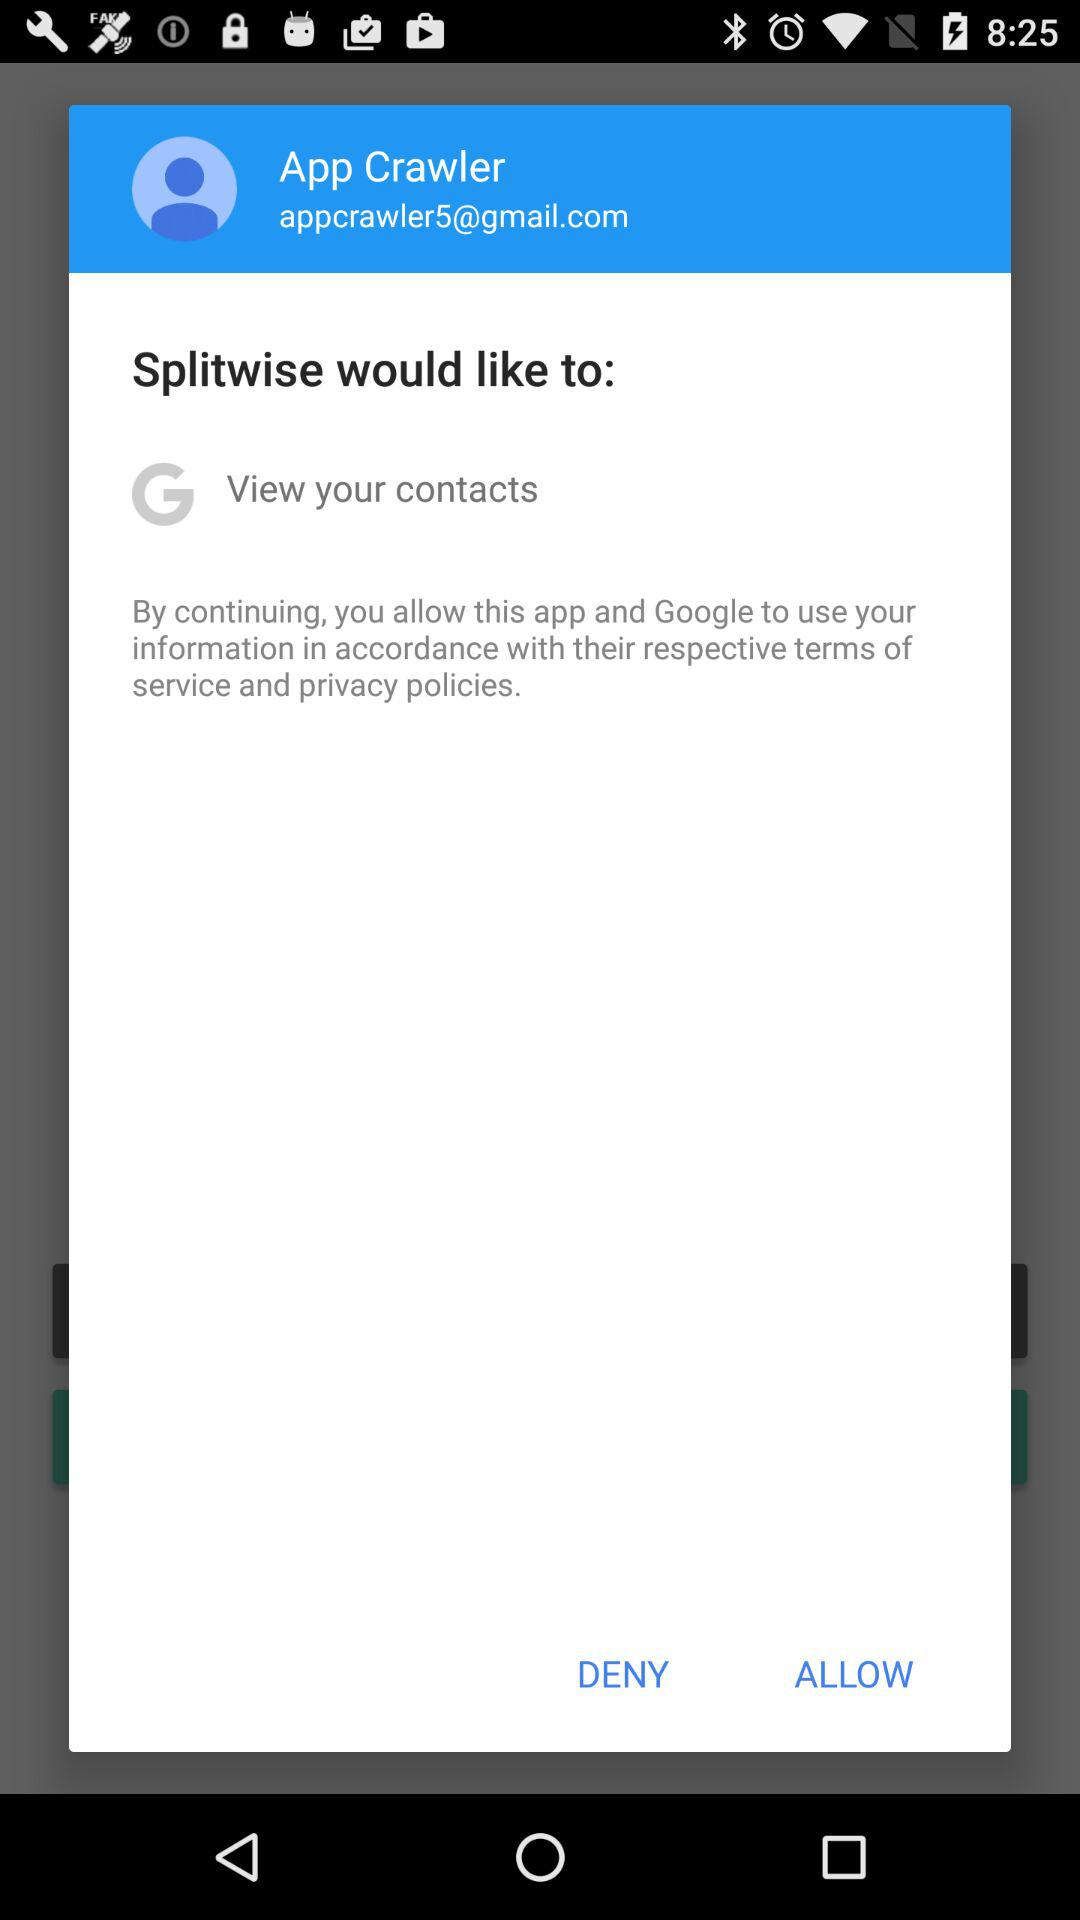What is the user name? The user name is App Crawler. 